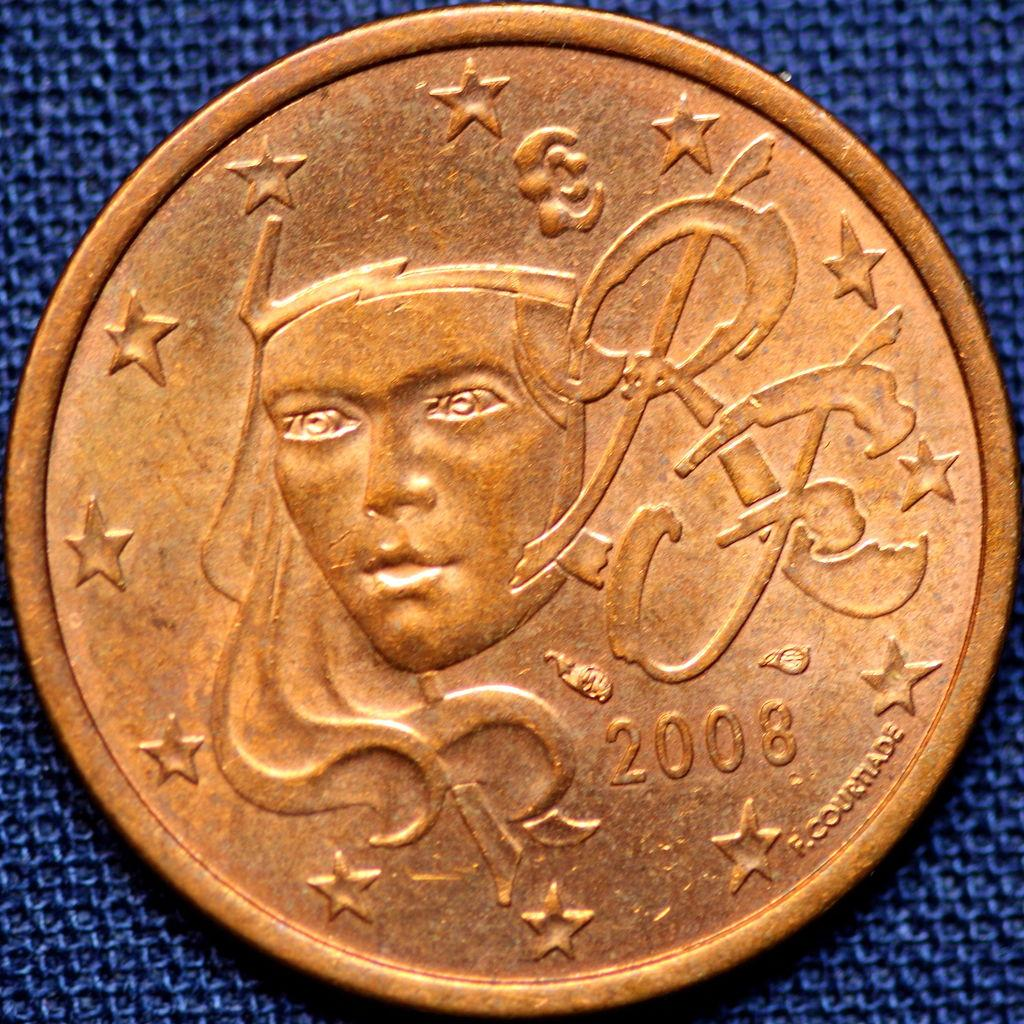What object is the main focus of the image? There is a coin in the image. What is depicted on the coin? The coin has a person depicted on it. What additional information is displayed on the coin? The coin has a year displayed on it, as well as text and symbols. What is the weight of the brick in the image? There is no brick present in the image, so it is not possible to determine its weight. 